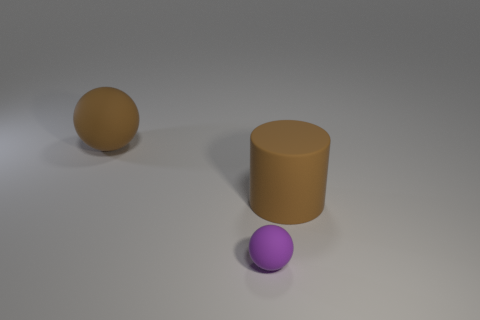There is a purple thing that is left of the large brown object that is to the right of the tiny purple matte thing; what is its size?
Your answer should be compact. Small. Does the small rubber ball have the same color as the rubber cylinder?
Provide a short and direct response. No. How many matte things are big cylinders or tiny purple things?
Give a very brief answer. 2. How many big brown things are there?
Give a very brief answer. 2. Are the object to the right of the small purple rubber sphere and the large brown object that is behind the cylinder made of the same material?
Your answer should be compact. Yes. What is the color of the large rubber object that is the same shape as the tiny purple thing?
Provide a short and direct response. Brown. The tiny sphere that is left of the big brown rubber thing right of the brown matte sphere is made of what material?
Offer a terse response. Rubber. Do the big object that is left of the tiny sphere and the big thing that is to the right of the small purple rubber thing have the same shape?
Give a very brief answer. No. There is a object that is in front of the big brown matte sphere and on the left side of the large brown rubber cylinder; how big is it?
Your answer should be compact. Small. What number of other things are there of the same color as the tiny sphere?
Provide a short and direct response. 0. 